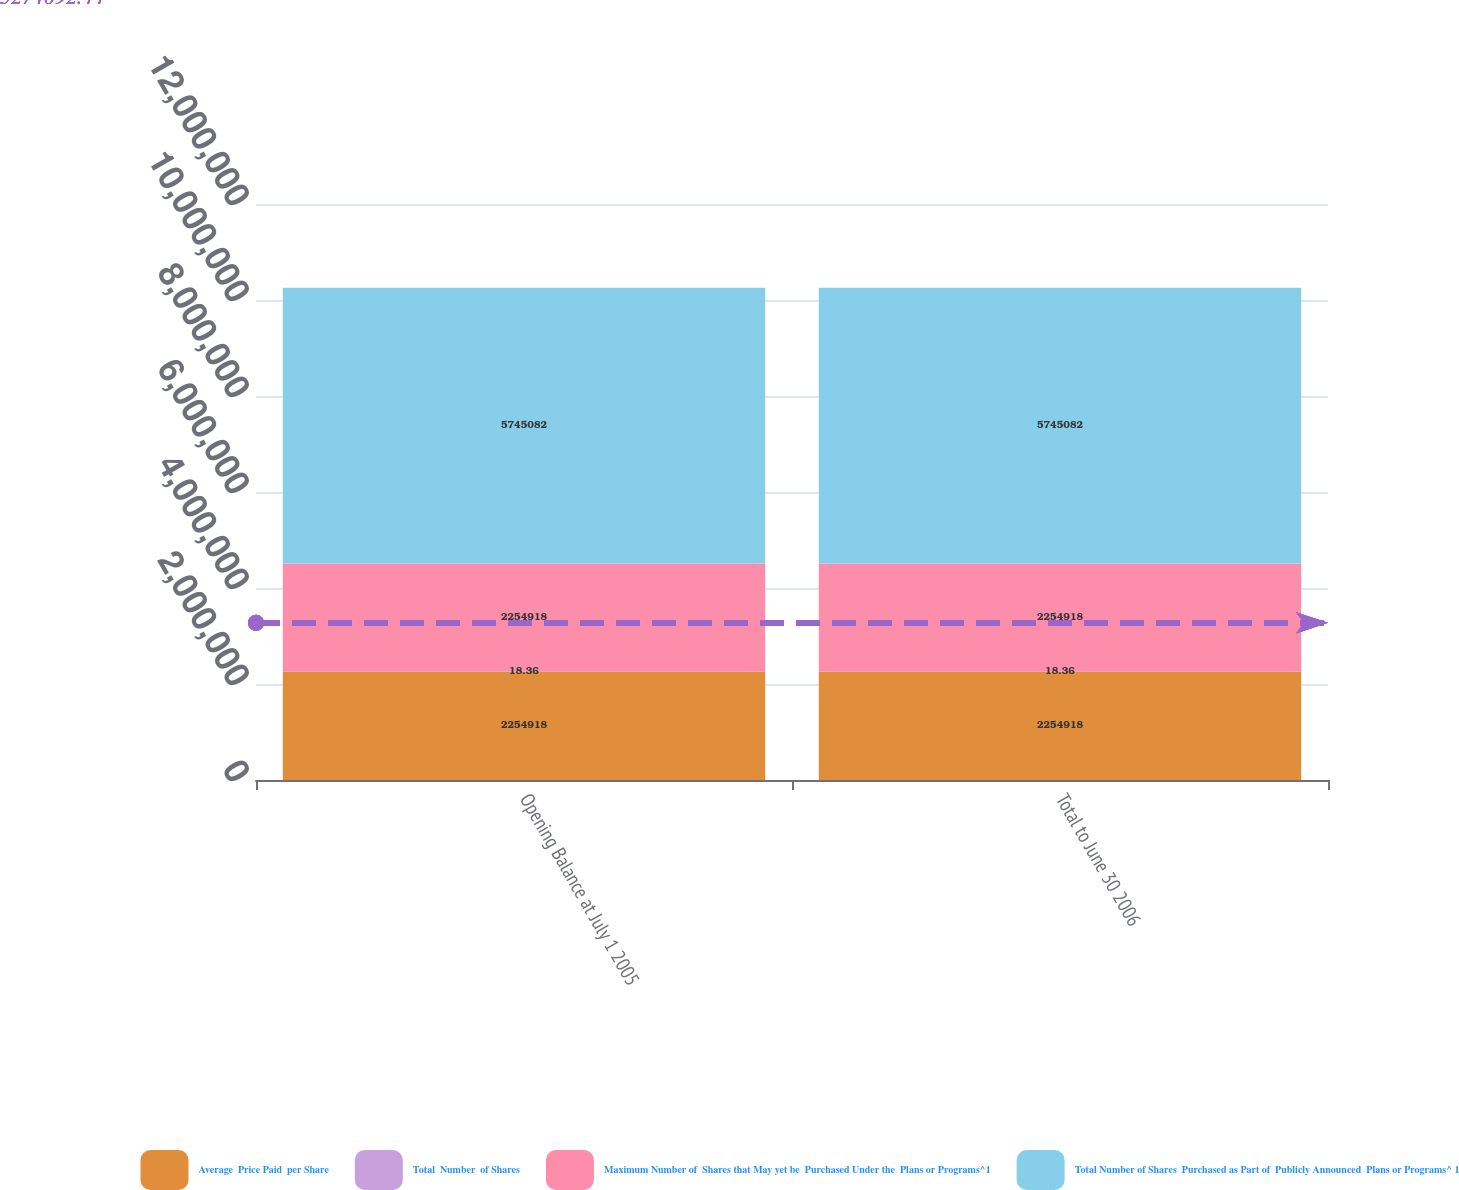Convert chart to OTSL. <chart><loc_0><loc_0><loc_500><loc_500><stacked_bar_chart><ecel><fcel>Opening Balance at July 1 2005<fcel>Total to June 30 2006<nl><fcel>Average  Price Paid  per Share<fcel>2.25492e+06<fcel>2.25492e+06<nl><fcel>Total  Number  of Shares<fcel>18.36<fcel>18.36<nl><fcel>Maximum Number of  Shares that May yet be  Purchased Under the  Plans or Programs^1<fcel>2.25492e+06<fcel>2.25492e+06<nl><fcel>Total Number of Shares  Purchased as Part of  Publicly Announced  Plans or Programs^ 1<fcel>5.74508e+06<fcel>5.74508e+06<nl></chart> 